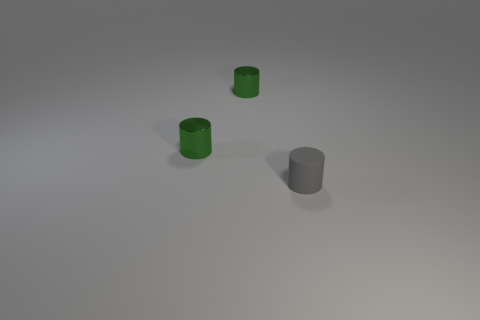How many green cylinders must be subtracted to get 1 green cylinders? 1 Subtract all green cylinders. How many cylinders are left? 1 Add 1 tiny gray cubes. How many objects exist? 4 Subtract all gray balls. How many green cylinders are left? 2 Subtract all gray cylinders. How many cylinders are left? 2 Subtract 3 cylinders. How many cylinders are left? 0 Subtract all metallic objects. Subtract all small gray objects. How many objects are left? 0 Add 3 small green metal cylinders. How many small green metal cylinders are left? 5 Add 1 cylinders. How many cylinders exist? 4 Subtract 0 yellow spheres. How many objects are left? 3 